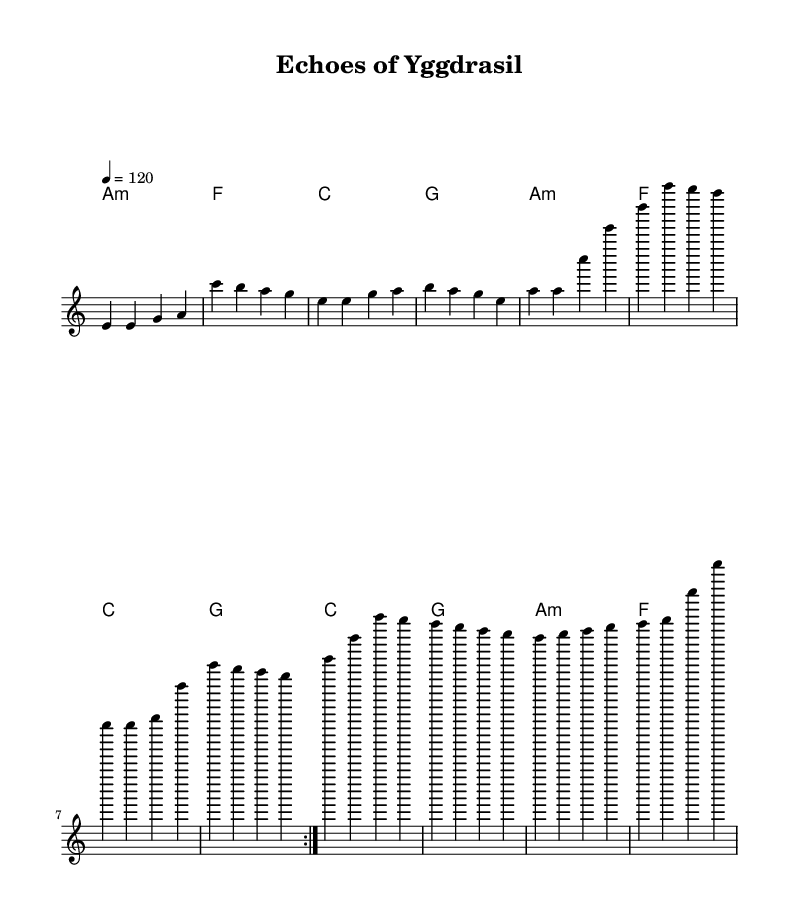What is the key signature of this music? The key signature is A minor, which has no sharps or flats, indicating that it is based on the A natural minor scale.
Answer: A minor What is the time signature of this music? The time signature shown in the sheet music is 4/4, which means there are four beats in each measure and a quarter note receives one beat.
Answer: 4/4 What is the tempo marking of this piece? The tempo marking indicates that the piece should be played at a speed of 120 beats per minute, denoting the speed of the music.
Answer: 120 How many times is the main section repeated? The main melody section is repeated twice, as indicated by the "repeat volta 2" directive in the score.
Answer: 2 What chords are used in the first section? The first section consists of the chords A minor, F, C, and G, which correspond to the harmonic progressions written above the melody.
Answer: A minor, F, C, G What is the highest note in the melody? The highest note in the melody is E' which is reached during the repeated sections, indicating a peak in the melodic line.
Answer: E' What type of song structure does this piece follow? This piece follows a verse structure, as suggested by the repetitious melodic phrases and the harmonic arrangement common in pop music.
Answer: Verse structure 